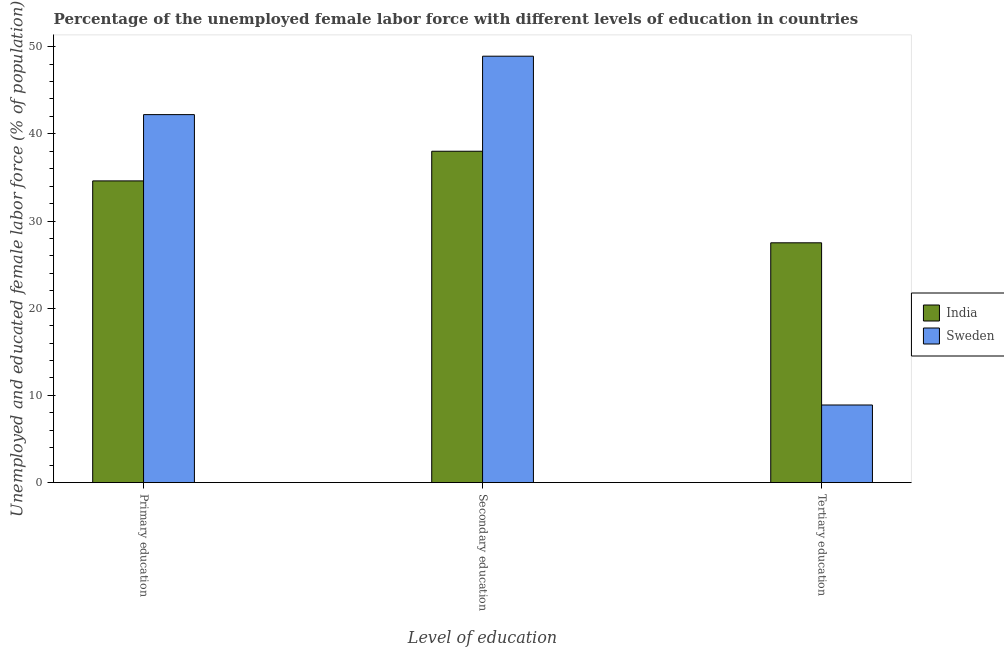How many different coloured bars are there?
Keep it short and to the point. 2. How many bars are there on the 3rd tick from the left?
Your answer should be compact. 2. What is the label of the 2nd group of bars from the left?
Offer a very short reply. Secondary education. What is the percentage of female labor force who received primary education in India?
Your answer should be very brief. 34.6. Across all countries, what is the maximum percentage of female labor force who received secondary education?
Ensure brevity in your answer.  48.9. Across all countries, what is the minimum percentage of female labor force who received tertiary education?
Your answer should be very brief. 8.9. In which country was the percentage of female labor force who received primary education minimum?
Make the answer very short. India. What is the total percentage of female labor force who received secondary education in the graph?
Ensure brevity in your answer.  86.9. What is the difference between the percentage of female labor force who received tertiary education in Sweden and that in India?
Your answer should be compact. -18.6. What is the difference between the percentage of female labor force who received tertiary education in India and the percentage of female labor force who received primary education in Sweden?
Give a very brief answer. -14.7. What is the average percentage of female labor force who received primary education per country?
Make the answer very short. 38.4. What is the difference between the percentage of female labor force who received primary education and percentage of female labor force who received tertiary education in India?
Make the answer very short. 7.1. What is the ratio of the percentage of female labor force who received tertiary education in Sweden to that in India?
Make the answer very short. 0.32. What is the difference between the highest and the second highest percentage of female labor force who received secondary education?
Ensure brevity in your answer.  10.9. What is the difference between the highest and the lowest percentage of female labor force who received primary education?
Give a very brief answer. 7.6. In how many countries, is the percentage of female labor force who received primary education greater than the average percentage of female labor force who received primary education taken over all countries?
Provide a succinct answer. 1. What does the 2nd bar from the left in Tertiary education represents?
Keep it short and to the point. Sweden. Is it the case that in every country, the sum of the percentage of female labor force who received primary education and percentage of female labor force who received secondary education is greater than the percentage of female labor force who received tertiary education?
Keep it short and to the point. Yes. Are the values on the major ticks of Y-axis written in scientific E-notation?
Provide a succinct answer. No. Does the graph contain grids?
Make the answer very short. No. Where does the legend appear in the graph?
Your answer should be very brief. Center right. How are the legend labels stacked?
Ensure brevity in your answer.  Vertical. What is the title of the graph?
Make the answer very short. Percentage of the unemployed female labor force with different levels of education in countries. What is the label or title of the X-axis?
Your answer should be compact. Level of education. What is the label or title of the Y-axis?
Ensure brevity in your answer.  Unemployed and educated female labor force (% of population). What is the Unemployed and educated female labor force (% of population) of India in Primary education?
Offer a terse response. 34.6. What is the Unemployed and educated female labor force (% of population) in Sweden in Primary education?
Your answer should be very brief. 42.2. What is the Unemployed and educated female labor force (% of population) in Sweden in Secondary education?
Your answer should be very brief. 48.9. What is the Unemployed and educated female labor force (% of population) of Sweden in Tertiary education?
Keep it short and to the point. 8.9. Across all Level of education, what is the maximum Unemployed and educated female labor force (% of population) of India?
Your answer should be compact. 38. Across all Level of education, what is the maximum Unemployed and educated female labor force (% of population) of Sweden?
Offer a very short reply. 48.9. Across all Level of education, what is the minimum Unemployed and educated female labor force (% of population) in Sweden?
Your response must be concise. 8.9. What is the total Unemployed and educated female labor force (% of population) in India in the graph?
Ensure brevity in your answer.  100.1. What is the total Unemployed and educated female labor force (% of population) in Sweden in the graph?
Provide a succinct answer. 100. What is the difference between the Unemployed and educated female labor force (% of population) in India in Primary education and that in Tertiary education?
Your answer should be compact. 7.1. What is the difference between the Unemployed and educated female labor force (% of population) of Sweden in Primary education and that in Tertiary education?
Your response must be concise. 33.3. What is the difference between the Unemployed and educated female labor force (% of population) of India in Secondary education and that in Tertiary education?
Offer a very short reply. 10.5. What is the difference between the Unemployed and educated female labor force (% of population) in Sweden in Secondary education and that in Tertiary education?
Offer a terse response. 40. What is the difference between the Unemployed and educated female labor force (% of population) of India in Primary education and the Unemployed and educated female labor force (% of population) of Sweden in Secondary education?
Make the answer very short. -14.3. What is the difference between the Unemployed and educated female labor force (% of population) of India in Primary education and the Unemployed and educated female labor force (% of population) of Sweden in Tertiary education?
Make the answer very short. 25.7. What is the difference between the Unemployed and educated female labor force (% of population) in India in Secondary education and the Unemployed and educated female labor force (% of population) in Sweden in Tertiary education?
Offer a very short reply. 29.1. What is the average Unemployed and educated female labor force (% of population) of India per Level of education?
Give a very brief answer. 33.37. What is the average Unemployed and educated female labor force (% of population) of Sweden per Level of education?
Ensure brevity in your answer.  33.33. What is the difference between the Unemployed and educated female labor force (% of population) in India and Unemployed and educated female labor force (% of population) in Sweden in Primary education?
Give a very brief answer. -7.6. What is the difference between the Unemployed and educated female labor force (% of population) in India and Unemployed and educated female labor force (% of population) in Sweden in Tertiary education?
Ensure brevity in your answer.  18.6. What is the ratio of the Unemployed and educated female labor force (% of population) in India in Primary education to that in Secondary education?
Offer a very short reply. 0.91. What is the ratio of the Unemployed and educated female labor force (% of population) of Sweden in Primary education to that in Secondary education?
Provide a succinct answer. 0.86. What is the ratio of the Unemployed and educated female labor force (% of population) of India in Primary education to that in Tertiary education?
Provide a short and direct response. 1.26. What is the ratio of the Unemployed and educated female labor force (% of population) of Sweden in Primary education to that in Tertiary education?
Provide a short and direct response. 4.74. What is the ratio of the Unemployed and educated female labor force (% of population) of India in Secondary education to that in Tertiary education?
Your answer should be compact. 1.38. What is the ratio of the Unemployed and educated female labor force (% of population) of Sweden in Secondary education to that in Tertiary education?
Keep it short and to the point. 5.49. 